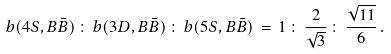Convert formula to latex. <formula><loc_0><loc_0><loc_500><loc_500>b ( 4 S , B \bar { B } ) \, \colon \, b ( 3 D , B \bar { B } ) \, \colon \, b ( 5 S , B \bar { B } ) \, = \, 1 \, \colon \, \frac { 2 } { \sqrt { 3 } } \, \colon \, \frac { \sqrt { 1 1 } } { 6 } \, .</formula> 